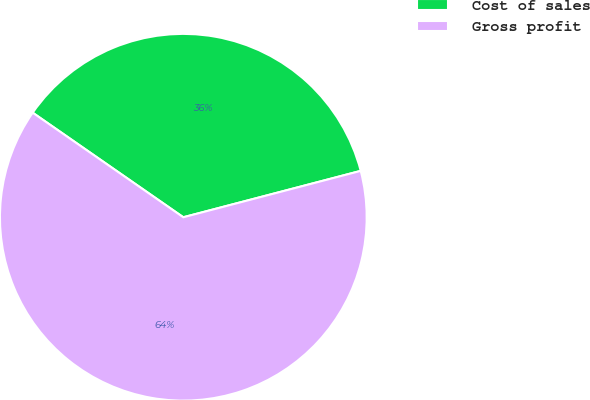Convert chart. <chart><loc_0><loc_0><loc_500><loc_500><pie_chart><fcel>Cost of sales<fcel>Gross profit<nl><fcel>36.27%<fcel>63.73%<nl></chart> 